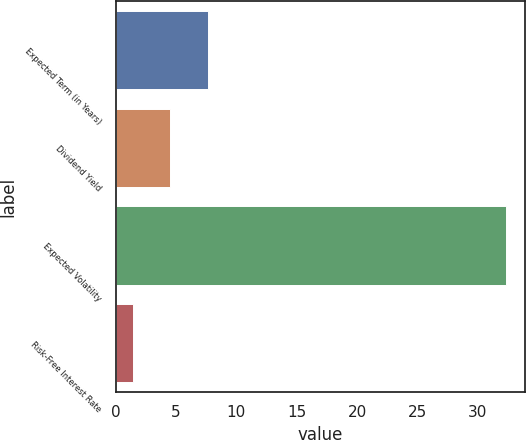<chart> <loc_0><loc_0><loc_500><loc_500><bar_chart><fcel>Expected Term (in Years)<fcel>Dividend Yield<fcel>Expected Volatility<fcel>Risk-Free Interest Rate<nl><fcel>7.62<fcel>4.54<fcel>32.3<fcel>1.45<nl></chart> 